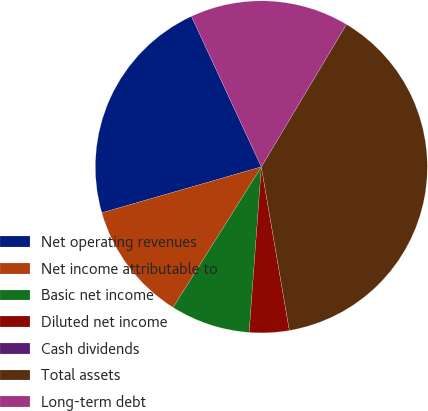Convert chart. <chart><loc_0><loc_0><loc_500><loc_500><pie_chart><fcel>Net operating revenues<fcel>Net income attributable to<fcel>Basic net income<fcel>Diluted net income<fcel>Cash dividends<fcel>Total assets<fcel>Long-term debt<nl><fcel>22.54%<fcel>11.62%<fcel>7.75%<fcel>3.87%<fcel>0.0%<fcel>38.73%<fcel>15.49%<nl></chart> 